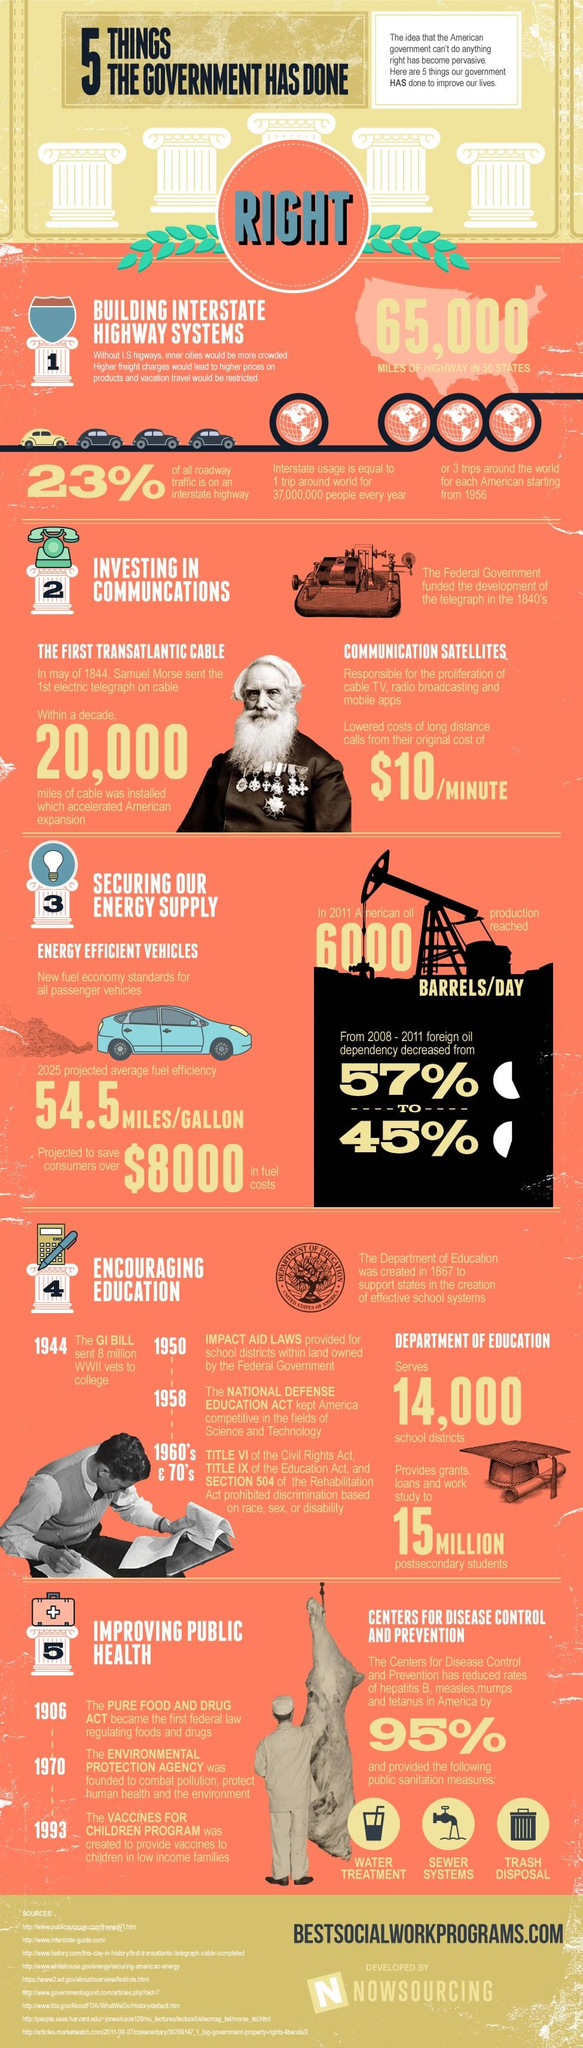Draw attention to some important aspects in this diagram. In 2011, the dependency on foreign oil was 45%. Samuel Morse was the person who introduced the telegraph. Long distance calls initially cost $10 per minute. It is estimated that 65,000 miles of highway have been constructed. In the year 23 after the founding of the Environmental Protection Agency, the Vaccine for Children program was established. 